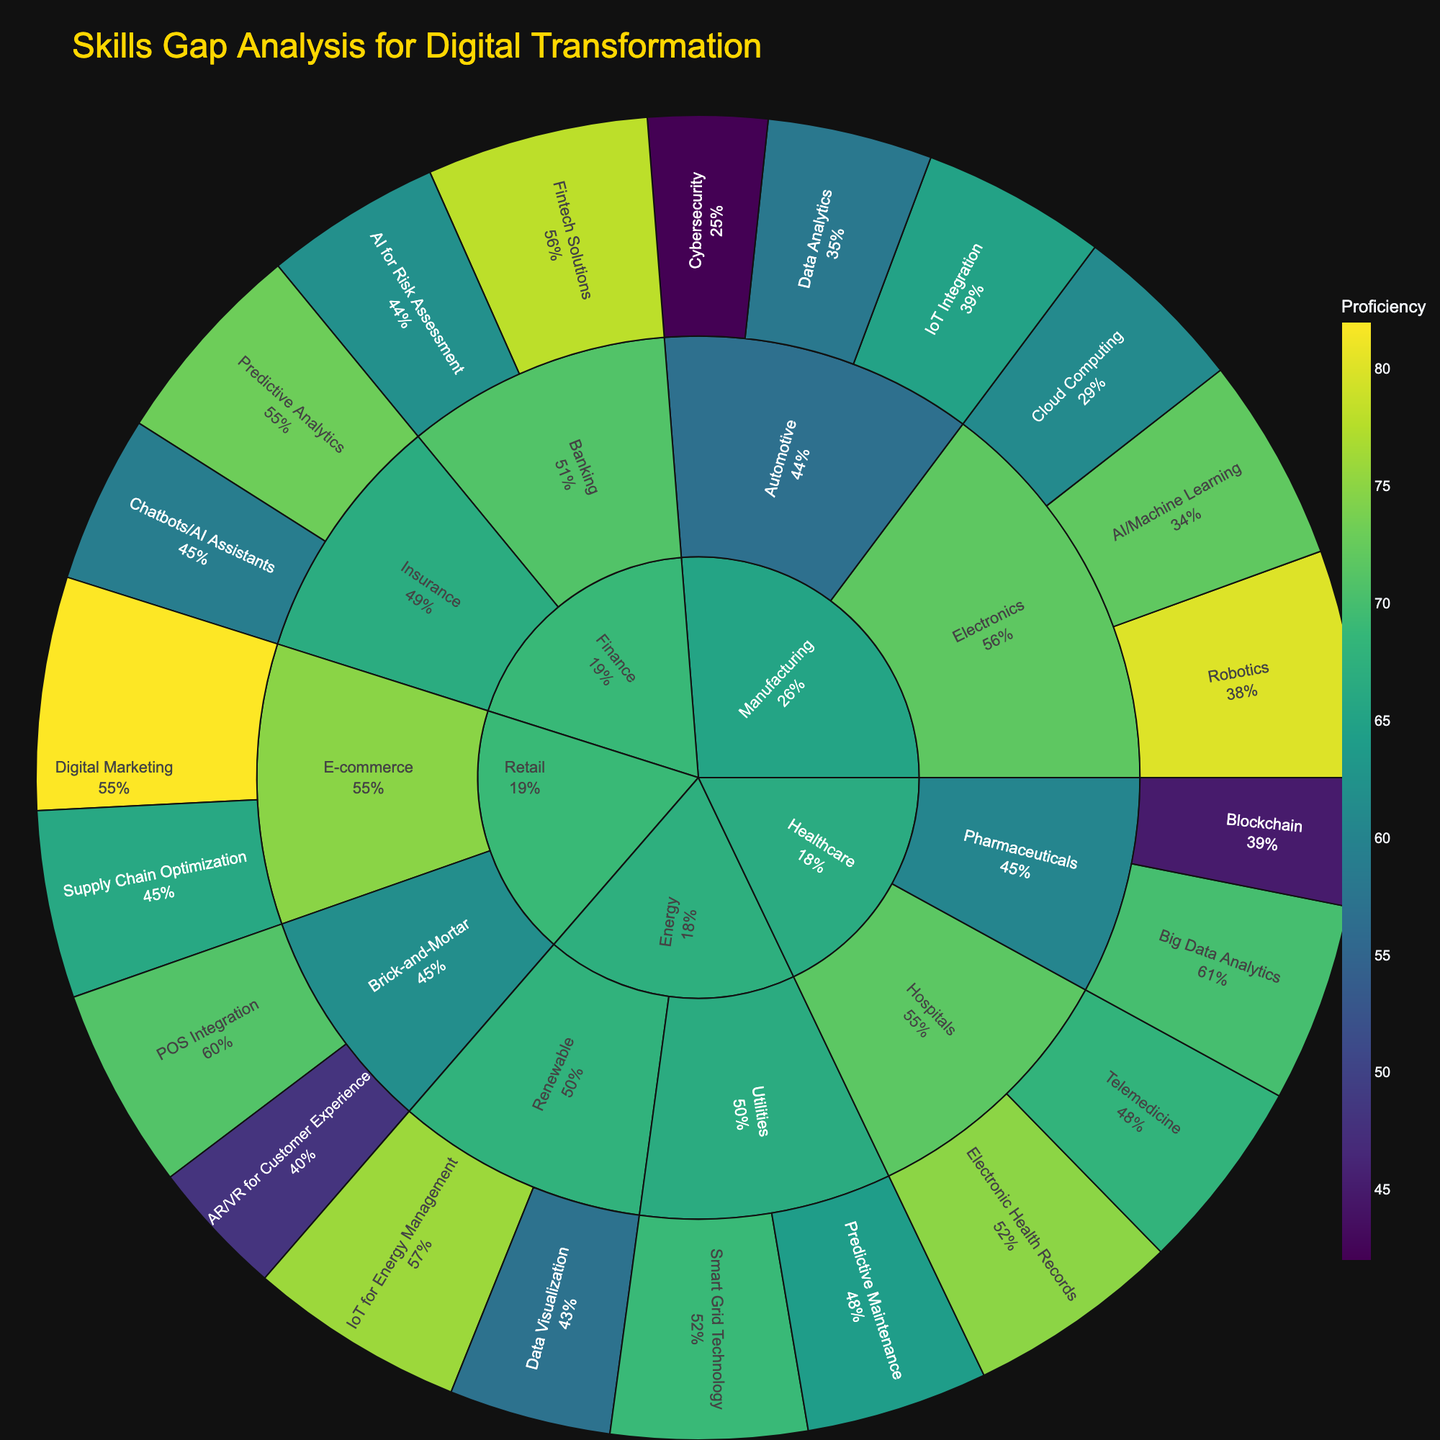What is the title of the plot? The title is displayed at the top of the plot, usually in a larger or more noticeable font to draw attention. The title helps viewers understand the overall subject of the visual representation.
Answer: Skills Gap Analysis for Digital Transformation Which skill in the Manufacturing sector has the highest proficiency? Within the Manufacturing sector, look at the proficiency values for all skills. Compare these values to identify the highest one. The skill with the highest value will be the one with the highest proficiency.
Answer: Robotics Which sector in the Healthcare industry has the lowest proficiency skill? Examine the proficiency values within each sector in the Healthcare industry. Identify the lowest proficiency value and the corresponding skill and sector.
Answer: Pharmaceuticals, Blockchain How does the proficiency in AI for Risk Assessment in Banking compare to Predictive Analytics in Insurance? Look at the proficiency values for AI for Risk Assessment in Banking and Predictive Analytics in Insurance. Compare these values to see which is higher or if they are equal.
Answer: AI for Risk Assessment is 62, lower than Predictive Analytics at 73 What is the total proficiency for skills in the Renewable sector of the Energy industry? Sum the proficiency values of all skills within the Renewable sector (IoT for Energy Management and Data Visualization). IoT for Energy Management: 76 Data Visualization: 57 Total = 76 + 57 = 133
Answer: 133 Which industry has the highest overall proficiency in a single skill? Compare the highest proficiency values of all skills across different industries. Identify which industry has the skill with the highest proficiency value.
Answer: Retail, Digital Marketing What percentage of the Manufacturing sector's total proficiency does AI/Machine Learning represent in Electronics? Calculate the total proficiency for the Electronics sector (AI/Machine Learning: 72, Robotics: 80, Cloud Computing: 61). Total proficiency = 72 + 80 + 61 = 213. The percentage of AI/Machine Learning = (72 / 213) * 100.
Answer: 33.8% How does the proficiency of Telemedicine in Hospitals compare to Electronic Health Records? Compare the proficiency values of Telemedicine and Electronic Health Records within the Hospitals sector. Telemedicine: 68 Electronic Health Records: 75. Telemedicine proficiency is lower.
Answer: 68 < 75 Which skill in Energy, Renewable has a lower proficiency, and by how much? Compare the proficiency values of IoT for Energy Management (76) and Data Visualization (57). Subtract the lower proficiency from the higher one: 76 - 57 = 19. Data Visualization is lower by 19 points.
Answer: Data Visualization, 19 What is the average proficiency of all skills in Retail? Calculate the average proficiency by summing the proficiency values for all skills in Retail (Digital Marketing: 82, Supply Chain Optimization: 66, AR/VR for Customer Experience: 48, POS Integration: 71). The sum is 82 + 66 + 48 + 71 = 267. Average proficiency = 267 / 4 = 66.75
Answer: 66.75 